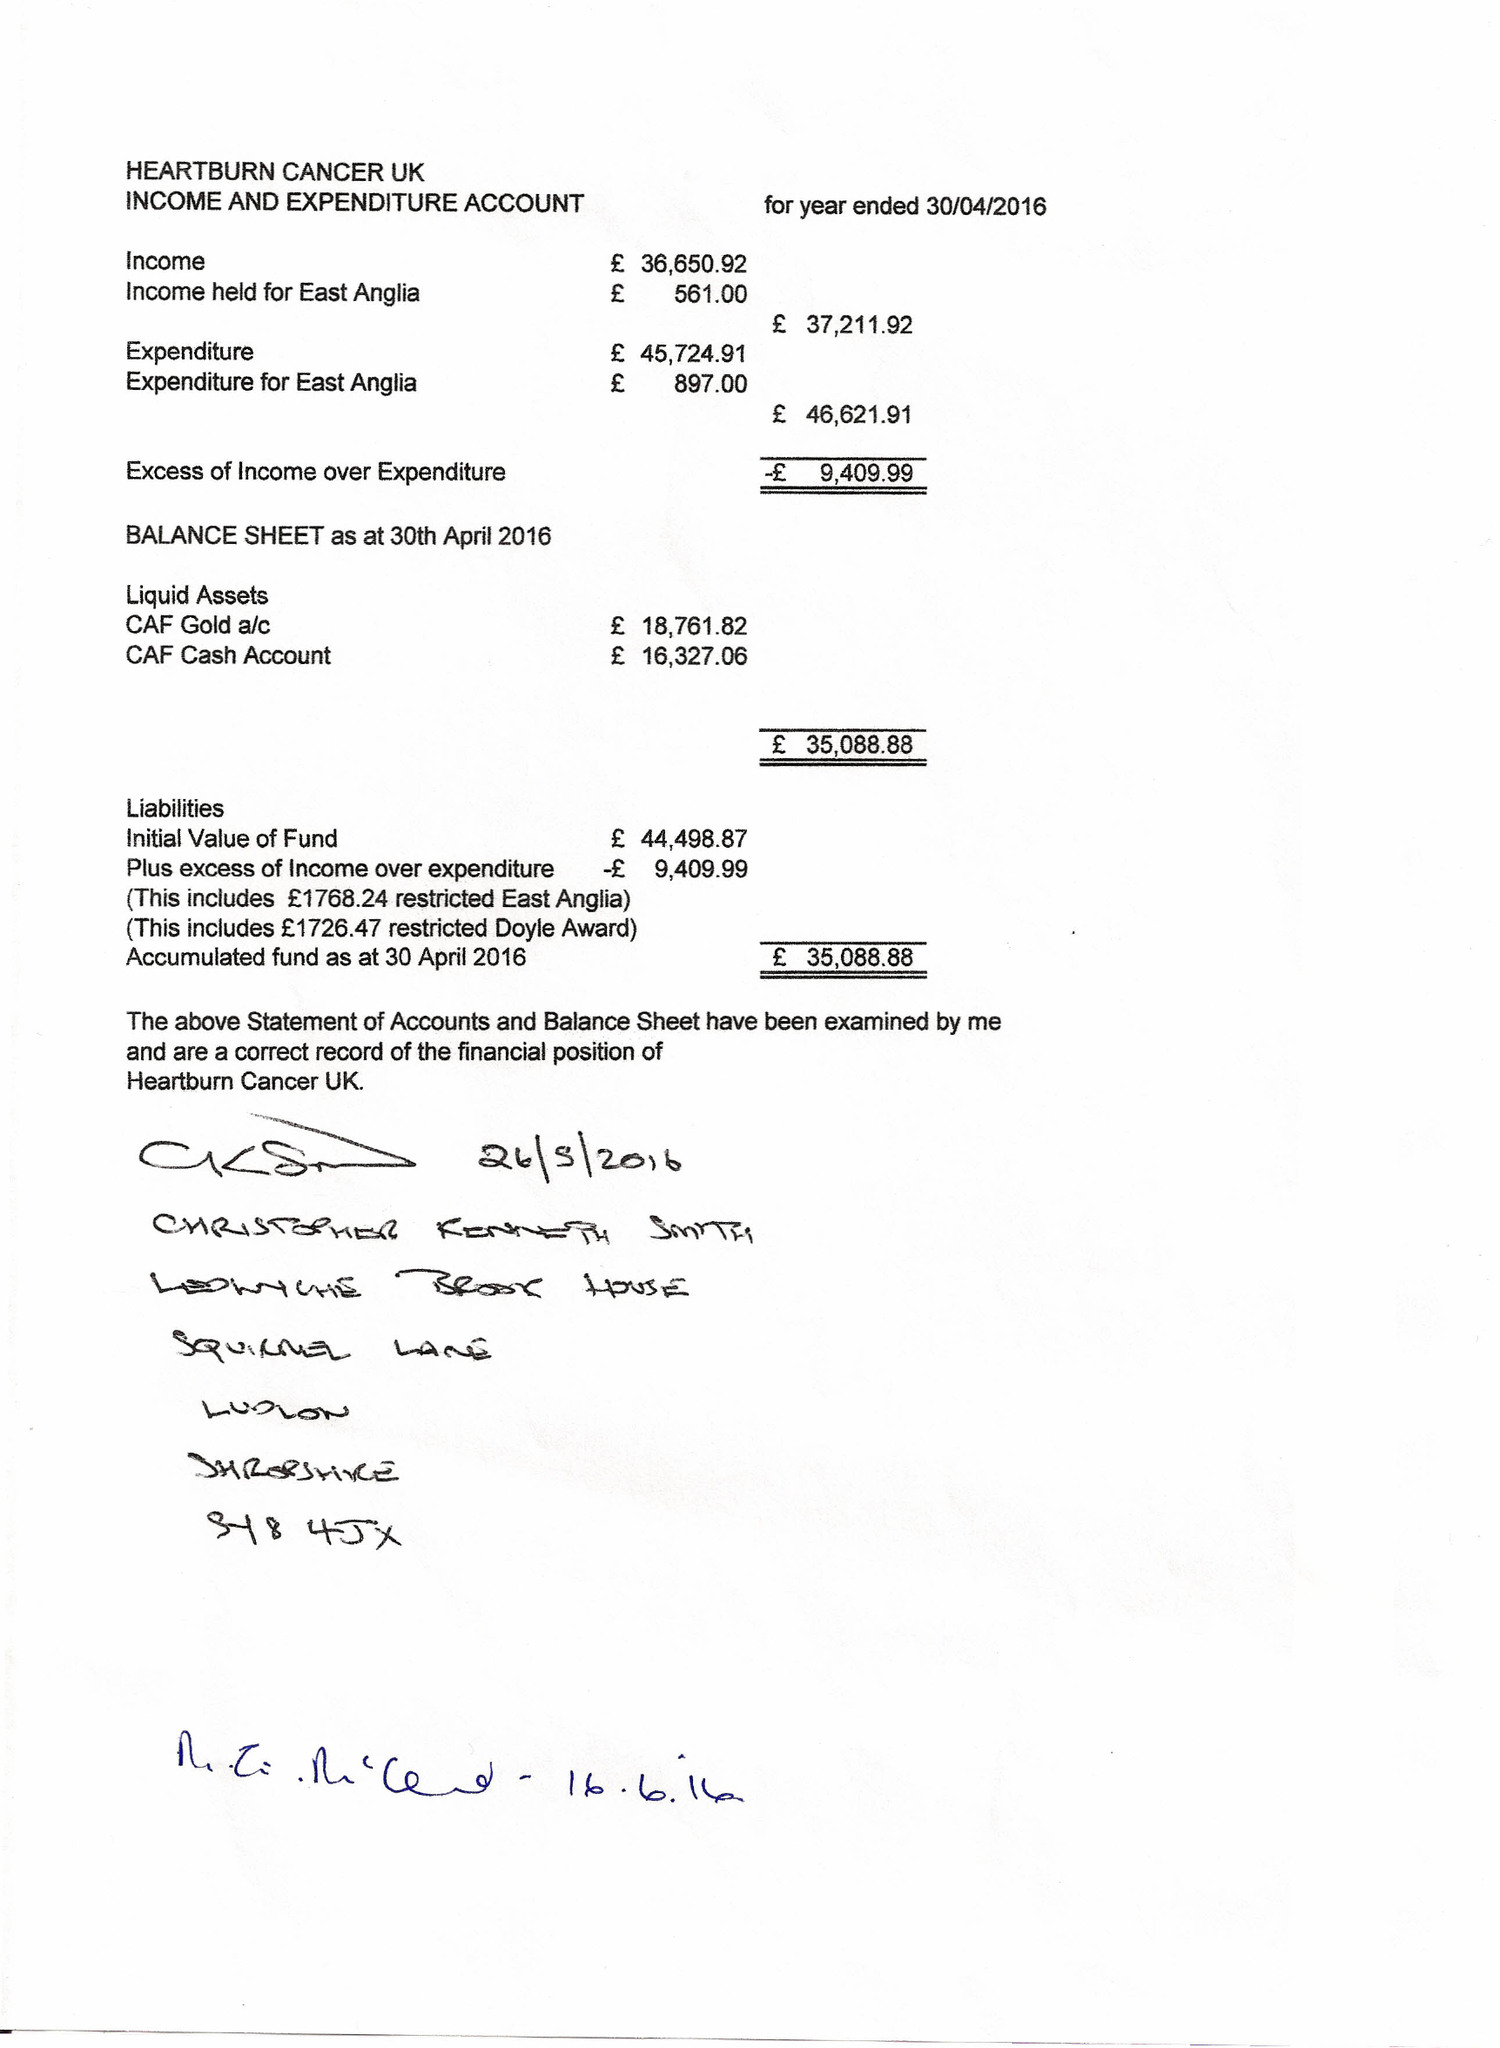What is the value for the spending_annually_in_british_pounds?
Answer the question using a single word or phrase. 46622.00 